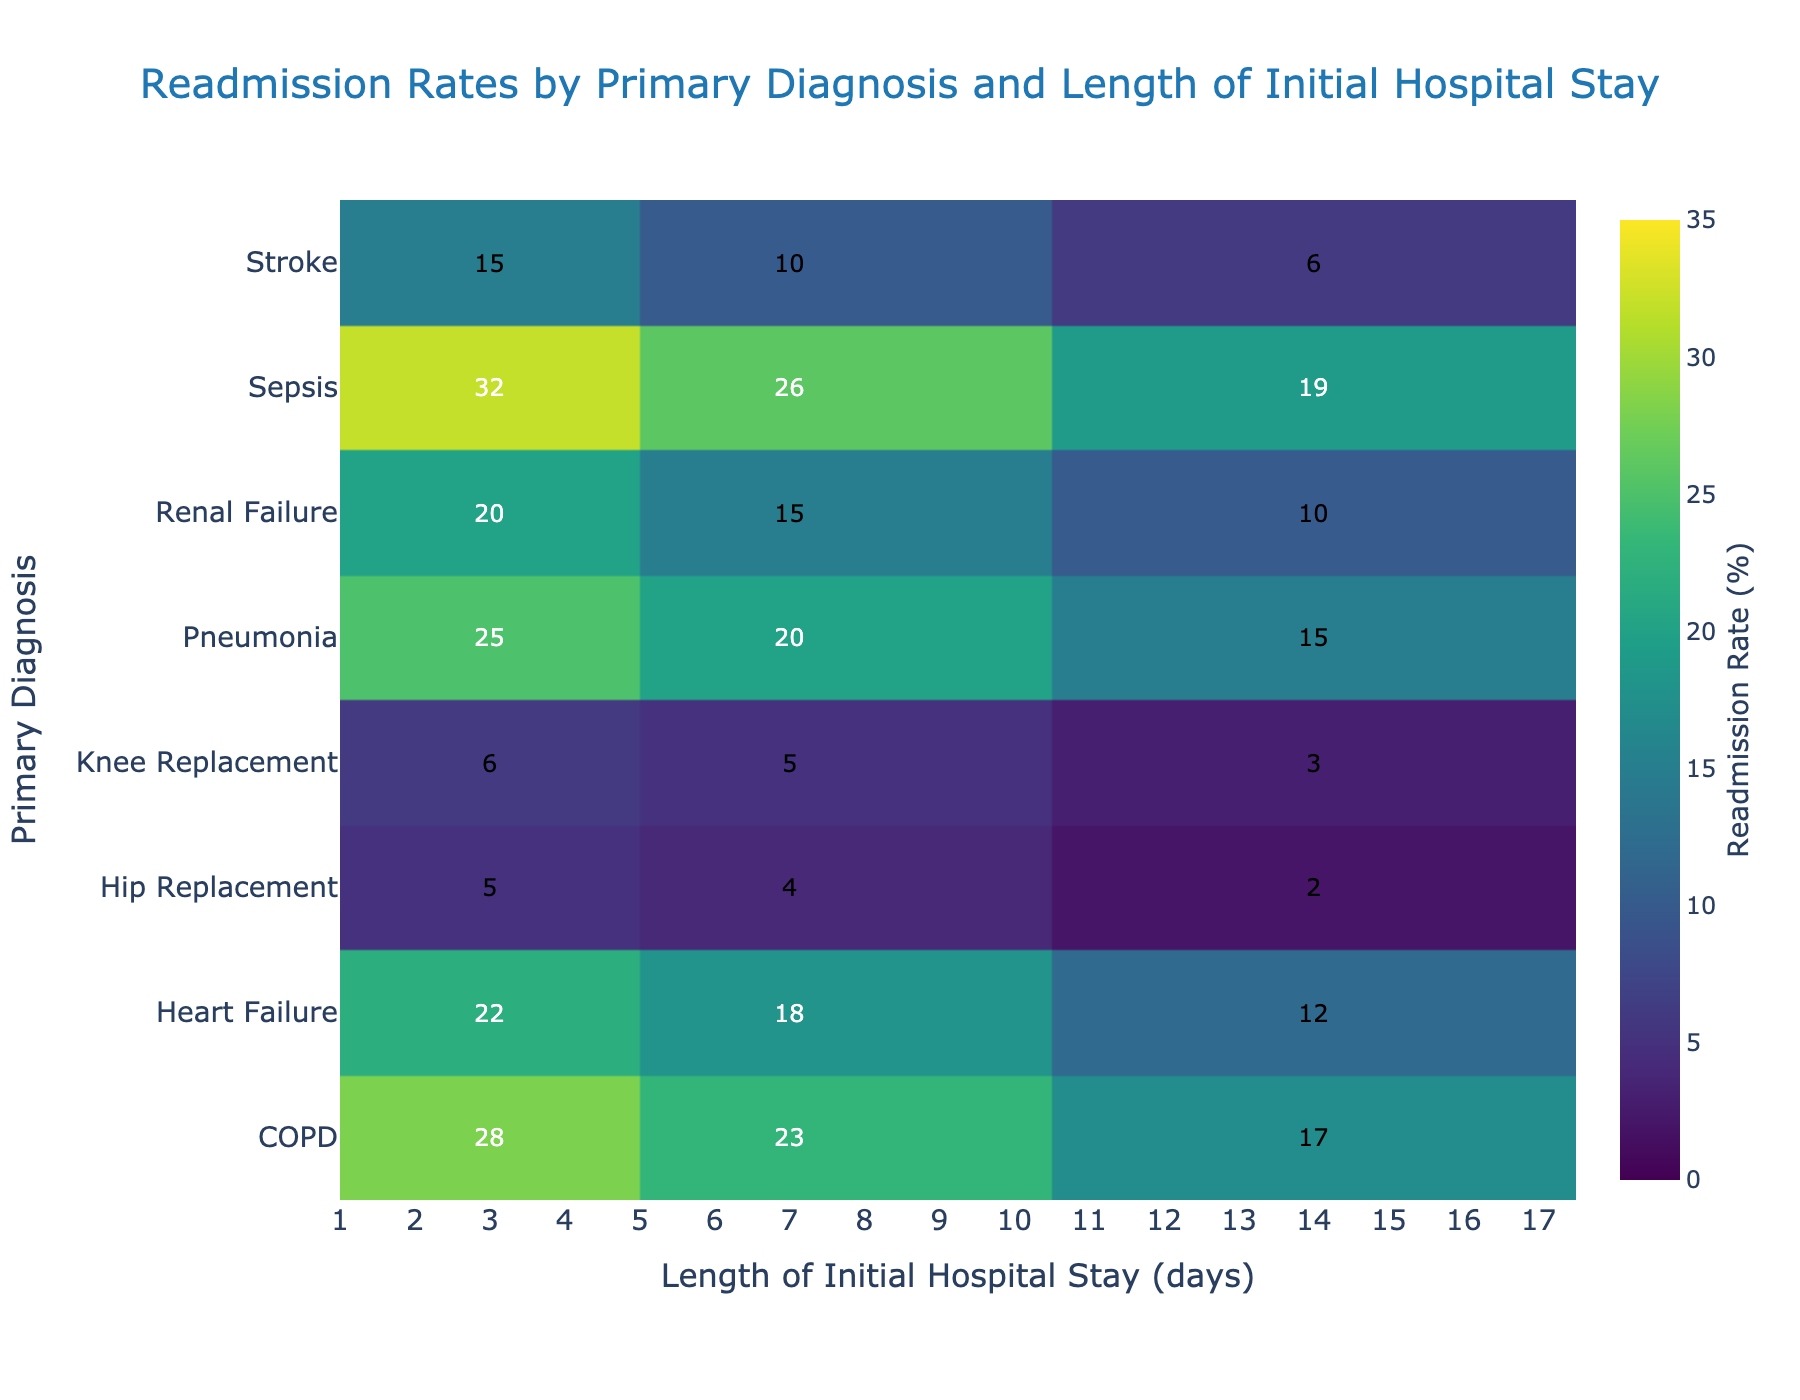What is the title of the heatmap? The title of the heatmap is usually located at the top and indicates the purpose or subject of the figure. Here, it reads "Readmission Rates by Primary Diagnosis and Length of Initial Hospital Stay"
Answer: Readmission Rates by Primary Diagnosis and Length of Initial Hospital Stay What is the readmission rate for patients with Stroke who stayed for 3 days? Locate the cell where the 'Primary Diagnosis' is 'Stroke' and the 'Length of Stay' is '3 days'. The value in this cell is 15%.
Answer: 15% Which primary diagnosis has the highest readmission rate for a 7-day stay? Look along the column for '7 days' and identify the highest value. The highest value in this column is 26% which corresponds to 'Sepsis'.
Answer: Sepsis What’s the difference in readmission rates for patients with Heart Failure between 3-day and 14-day stays? Find the readmission rates for 'Heart Failure' for 3 days (22%) and 14 days (12%). The difference is 22% - 12% = 10%.
Answer: 10% What is the trend in readmission rates for Sepsis with increasing length of stay? Observe the values for 'Sepsis' across the different lengths of stay (3, 7, and 14 days). The values are 32%, 26%, and 19% respectively, showing a decreasing trend.
Answer: Decreasing Which condition has the lowest readmission rate for a 14-day stay? Look along the column for '14 days' and find the smallest value. The lowest value in this column is 2% which corresponds to 'Hip Replacement'.
Answer: Hip Replacement Compare the readmission rates for COPD and Pneumonia for a 7-day stay. Which one is higher? The readmission rate for 'COPD' and 'Pneumonia' for 7 days are 23% and 20% respectively. Since 23% is greater than 20%, 'COPD' has a higher rate.
Answer: COPD What is the average readmission rate for Heart Failure across all lengths of stay? Add the readmission rates for 'Heart Failure' across 3, 7, and 14 days (22% + 18% + 12%) which equals 52%. Divide by 3 to get the average, 52% / 3 = approximately 17.33%.
Answer: 17.33% For which length of stay is the readmission rate for Renal Failure the lowest? Check the values for 'Renal Failure' across different lengths of stay and find the smallest value. The values are 20%, 15%, and 10%, with 10% being the lowest and corresponding to a 14-day stay.
Answer: 14 days 